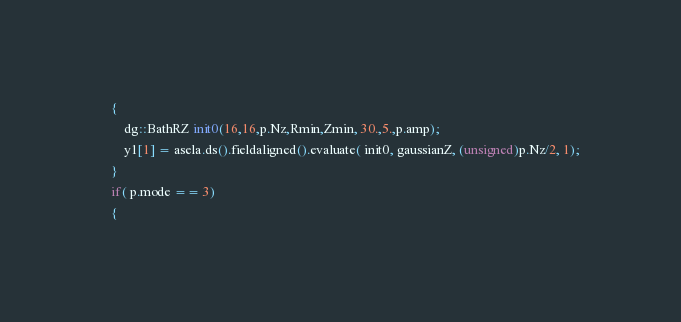Convert code to text. <code><loc_0><loc_0><loc_500><loc_500><_Cuda_>    {
        dg::BathRZ init0(16,16,p.Nz,Rmin,Zmin, 30.,5.,p.amp);
        y1[1] = asela.ds().fieldaligned().evaluate( init0, gaussianZ, (unsigned)p.Nz/2, 1); 
    }
    if( p.mode == 3)
    {</code> 